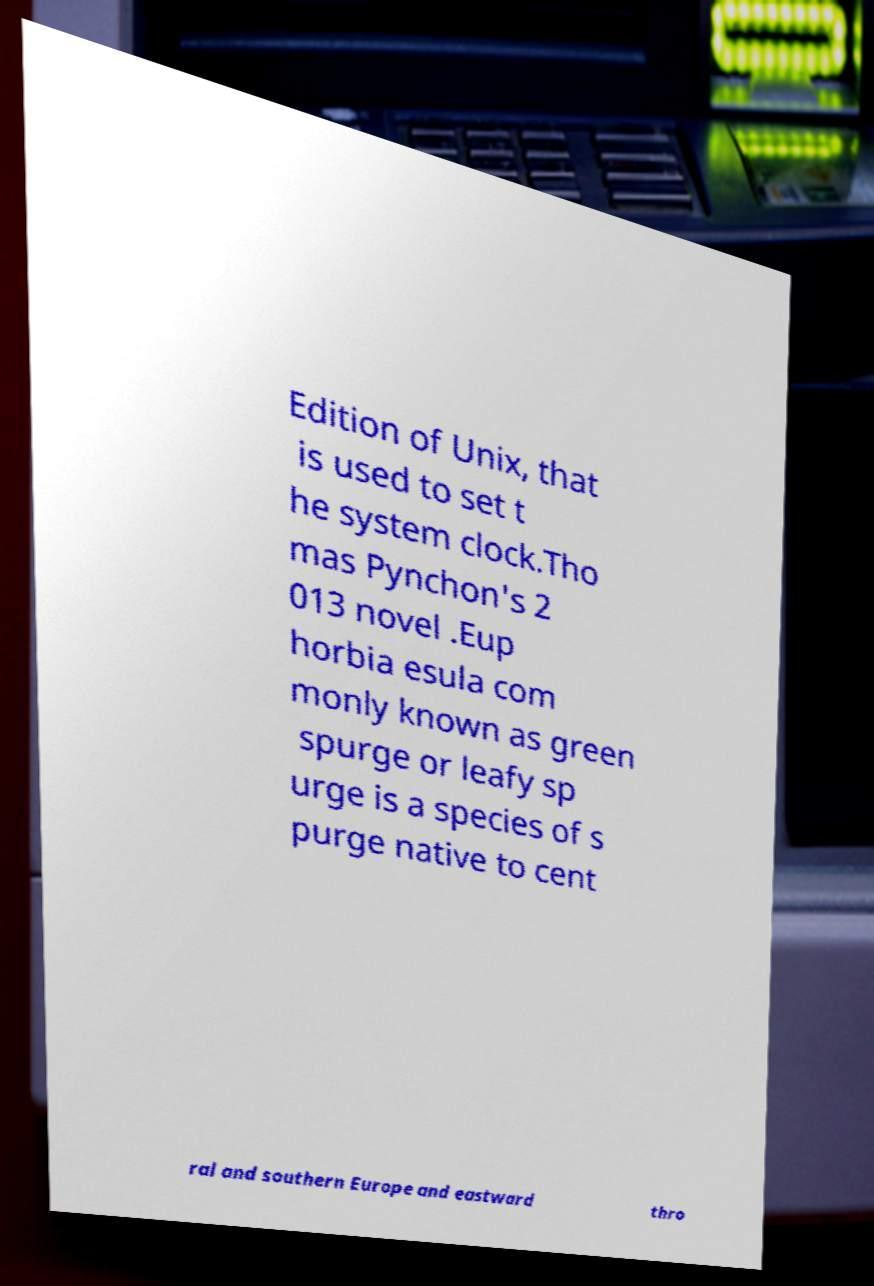What messages or text are displayed in this image? I need them in a readable, typed format. Edition of Unix, that is used to set t he system clock.Tho mas Pynchon's 2 013 novel .Eup horbia esula com monly known as green spurge or leafy sp urge is a species of s purge native to cent ral and southern Europe and eastward thro 